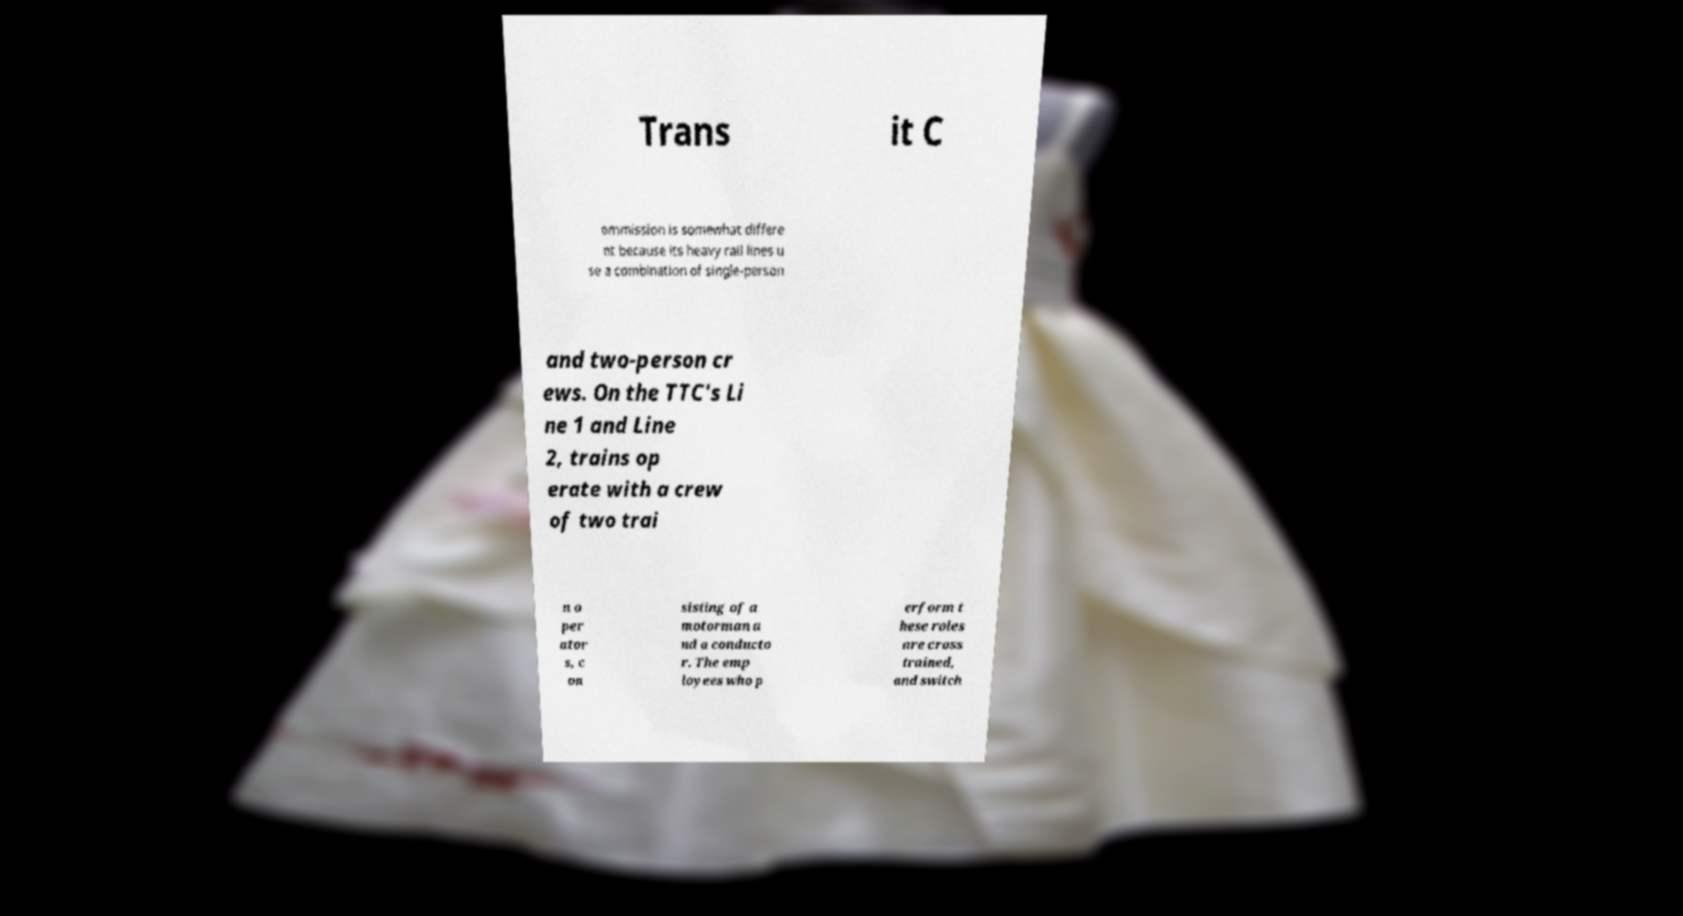Could you extract and type out the text from this image? Trans it C ommission is somewhat differe nt because its heavy rail lines u se a combination of single-person and two-person cr ews. On the TTC's Li ne 1 and Line 2, trains op erate with a crew of two trai n o per ator s, c on sisting of a motorman a nd a conducto r. The emp loyees who p erform t hese roles are cross trained, and switch 